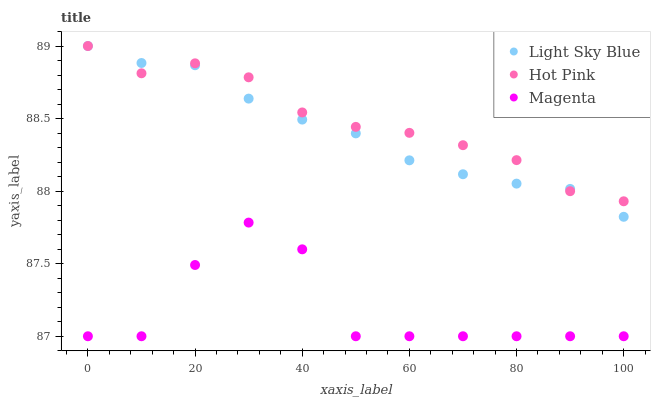Does Magenta have the minimum area under the curve?
Answer yes or no. Yes. Does Hot Pink have the maximum area under the curve?
Answer yes or no. Yes. Does Light Sky Blue have the minimum area under the curve?
Answer yes or no. No. Does Light Sky Blue have the maximum area under the curve?
Answer yes or no. No. Is Light Sky Blue the smoothest?
Answer yes or no. Yes. Is Magenta the roughest?
Answer yes or no. Yes. Is Hot Pink the smoothest?
Answer yes or no. No. Is Hot Pink the roughest?
Answer yes or no. No. Does Magenta have the lowest value?
Answer yes or no. Yes. Does Light Sky Blue have the lowest value?
Answer yes or no. No. Does Hot Pink have the highest value?
Answer yes or no. Yes. Is Magenta less than Light Sky Blue?
Answer yes or no. Yes. Is Light Sky Blue greater than Magenta?
Answer yes or no. Yes. Does Hot Pink intersect Light Sky Blue?
Answer yes or no. Yes. Is Hot Pink less than Light Sky Blue?
Answer yes or no. No. Is Hot Pink greater than Light Sky Blue?
Answer yes or no. No. Does Magenta intersect Light Sky Blue?
Answer yes or no. No. 